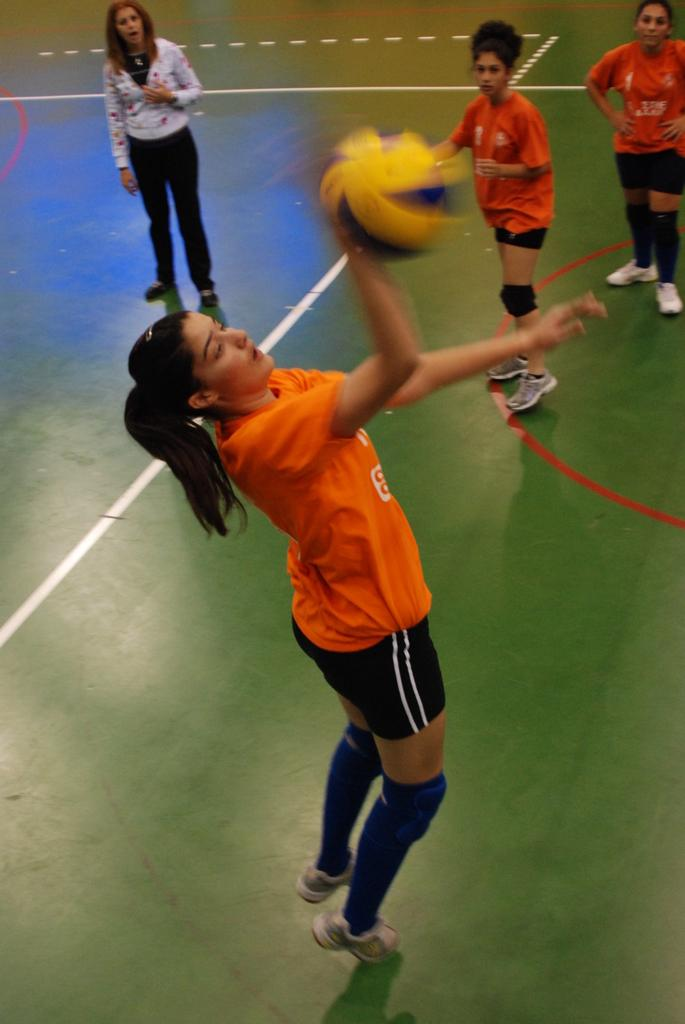What is the main subject of the image? The main subject of the image is a woman volleyball player. What is the woman doing in the image? The woman is hitting a ball in the image. Are there any other people in the image? Yes, there are two other volleyball players in the image. What are the other two players doing? The other two players are watching the woman. Are there any other individuals in the image? Yes, there is another woman in the image. What type of drum can be heard in the background of the image? There is no drum or any sound mentioned in the image; it is a still photograph of a volleyball scene. 